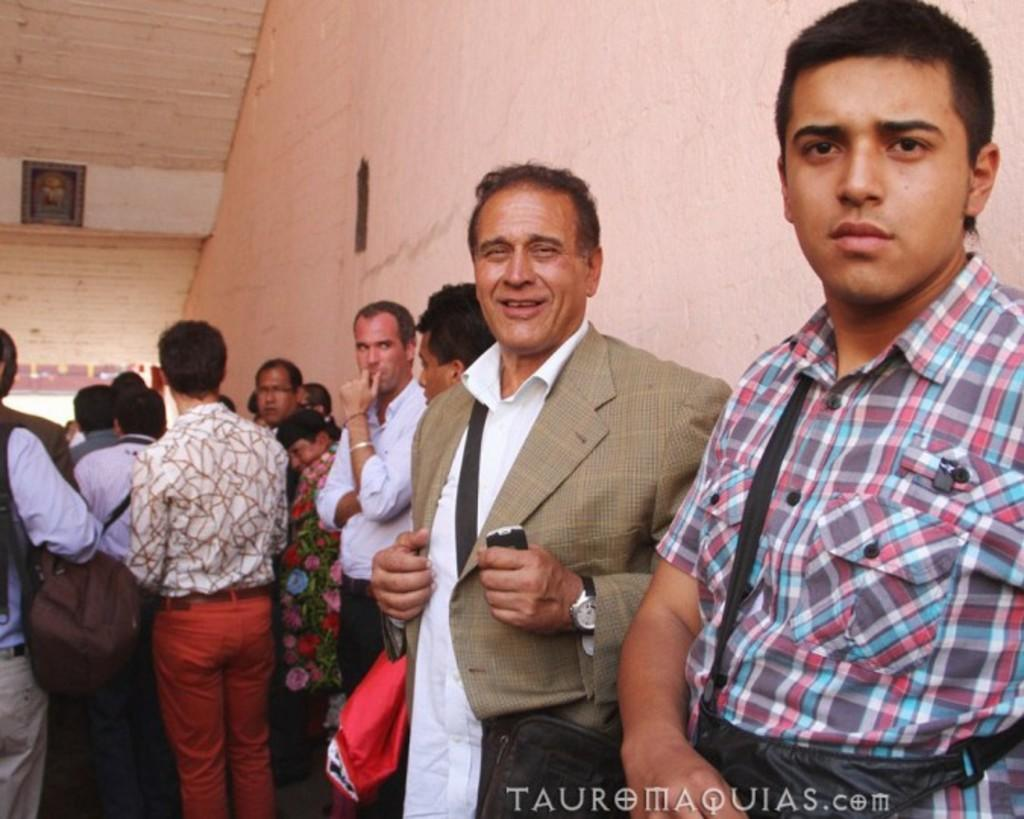What is happening in the center of the image? There are people standing in the center of the image. What can be seen in the background of the image? There is a wall in the background of the image. What time is indicated by the alarm in the image? There is no alarm present in the image. What type of blood is visible on the wall in the image? There is no blood visible on the wall in the image. 